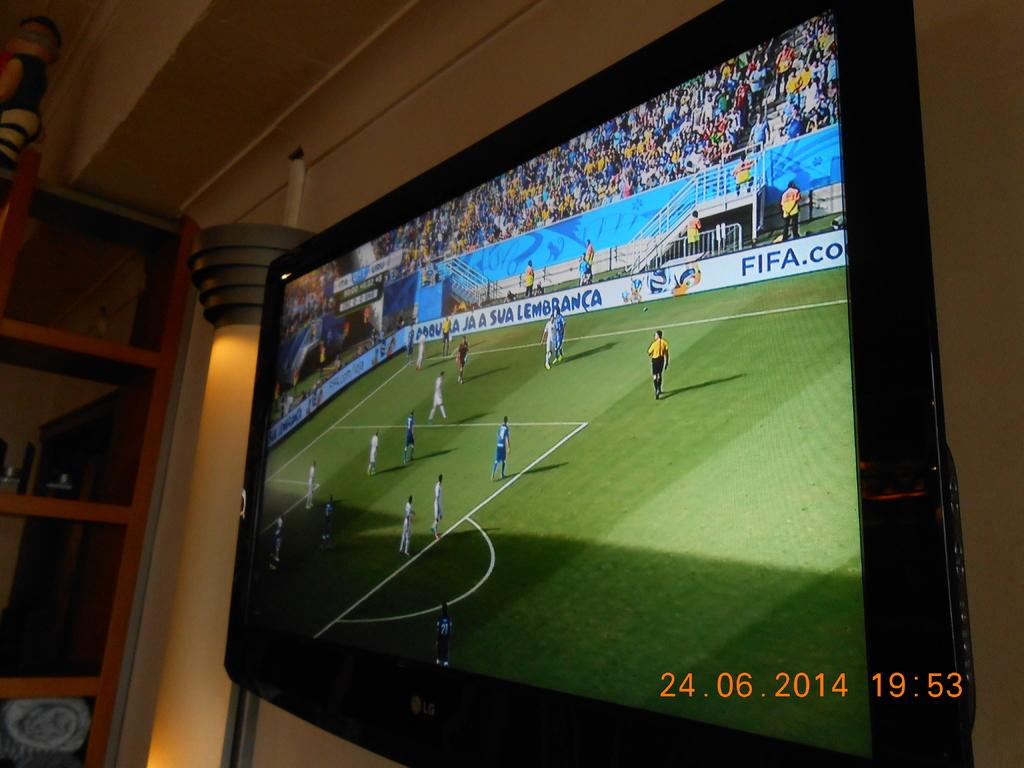<image>
Present a compact description of the photo's key features. Soccer game on an LG television that is dated 24.06.2014 19:53. 